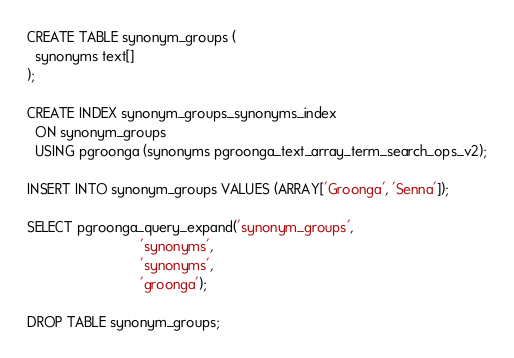Convert code to text. <code><loc_0><loc_0><loc_500><loc_500><_SQL_>CREATE TABLE synonym_groups (
  synonyms text[]
);

CREATE INDEX synonym_groups_synonyms_index
  ON synonym_groups
  USING pgroonga (synonyms pgroonga_text_array_term_search_ops_v2);

INSERT INTO synonym_groups VALUES (ARRAY['Groonga', 'Senna']);

SELECT pgroonga_query_expand('synonym_groups',
                             'synonyms',
                             'synonyms',
                             'groonga');

DROP TABLE synonym_groups;
</code> 